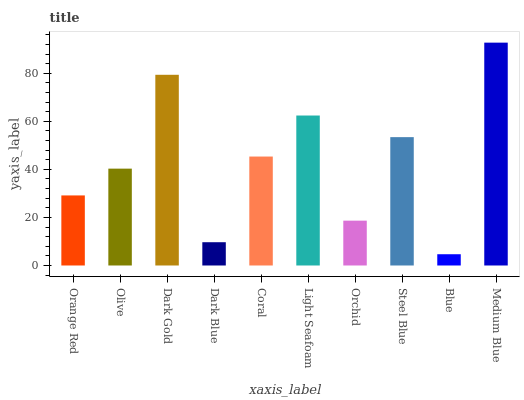Is Blue the minimum?
Answer yes or no. Yes. Is Medium Blue the maximum?
Answer yes or no. Yes. Is Olive the minimum?
Answer yes or no. No. Is Olive the maximum?
Answer yes or no. No. Is Olive greater than Orange Red?
Answer yes or no. Yes. Is Orange Red less than Olive?
Answer yes or no. Yes. Is Orange Red greater than Olive?
Answer yes or no. No. Is Olive less than Orange Red?
Answer yes or no. No. Is Coral the high median?
Answer yes or no. Yes. Is Olive the low median?
Answer yes or no. Yes. Is Olive the high median?
Answer yes or no. No. Is Dark Gold the low median?
Answer yes or no. No. 